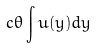Convert formula to latex. <formula><loc_0><loc_0><loc_500><loc_500>c \theta \int u ( y ) d y</formula> 